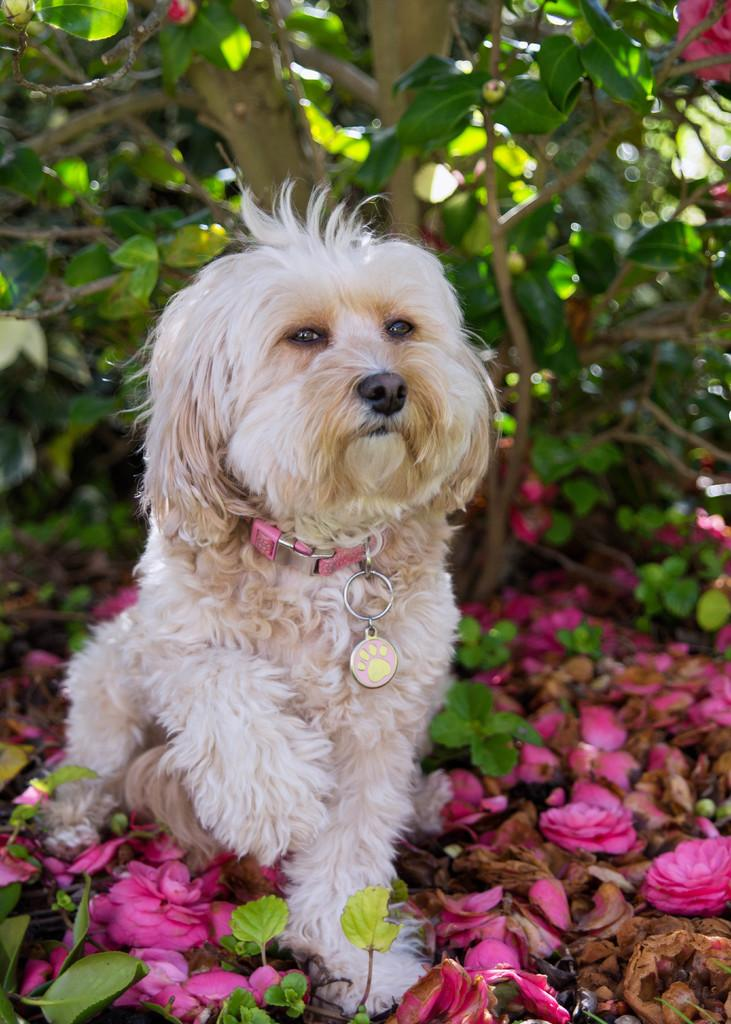What can be seen in the foreground of the picture? In the foreground of the picture, there are flowers, dry leaves, and leaves. Is there any living creature in the foreground of the picture? Yes, there is a dog in the foreground of the picture. What is visible in the background of the picture? There is a tree in the background of the picture. What type of berry can be seen hanging from the tree in the background? There is no berry present on the tree in the background; only leaves are visible. What color is the dog's neck in the foreground of the picture? The provided facts do not mention the color of the dog's neck, nor does the image show the dog's neck in detail. 